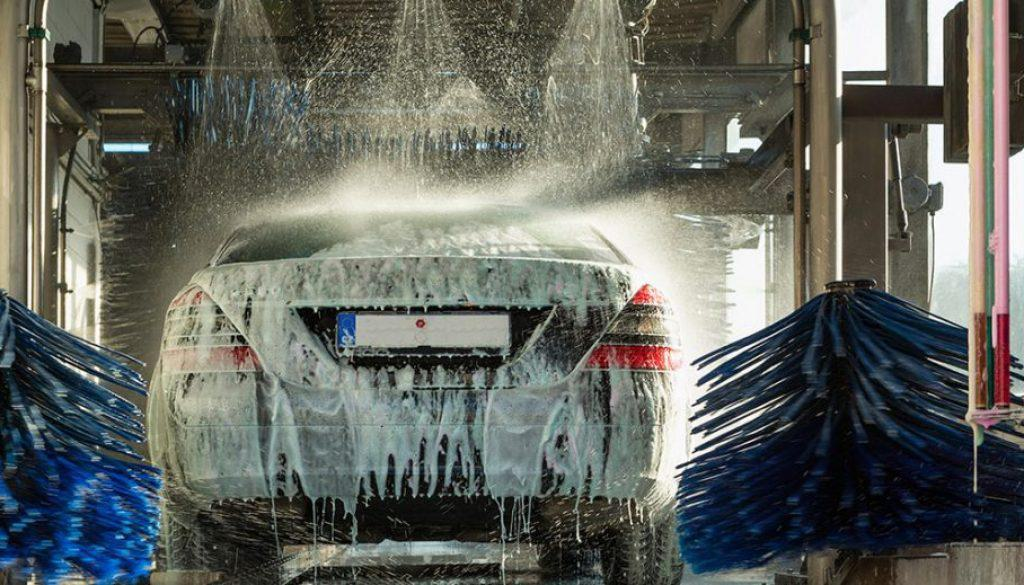What stage of the washing process is the car in? The car seems to be in the initial stages of the automated washing process where it is being doused with soap and water before the brushes scrub the surfaces clean. 